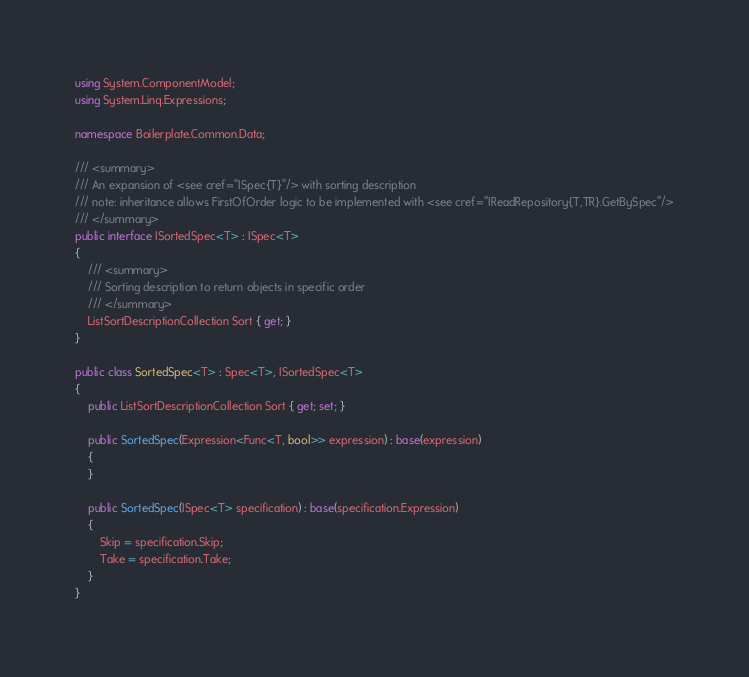<code> <loc_0><loc_0><loc_500><loc_500><_C#_>using System.ComponentModel;
using System.Linq.Expressions;

namespace Boilerplate.Common.Data;

/// <summary>
/// An expansion of <see cref="ISpec{T}"/> with sorting description
/// note: inheritance allows FirstOfOrder logic to be implemented with <see cref="IReadRepository{T,TR}.GetBySpec"/>
/// </summary>
public interface ISortedSpec<T> : ISpec<T>
{
    /// <summary>
    /// Sorting description to return objects in specific order
    /// </summary>
    ListSortDescriptionCollection Sort { get; }
}

public class SortedSpec<T> : Spec<T>, ISortedSpec<T>
{
    public ListSortDescriptionCollection Sort { get; set; }

    public SortedSpec(Expression<Func<T, bool>> expression) : base(expression)
    {
    }

    public SortedSpec(ISpec<T> specification) : base(specification.Expression)
    {
        Skip = specification.Skip;
        Take = specification.Take;
    }
}
</code> 